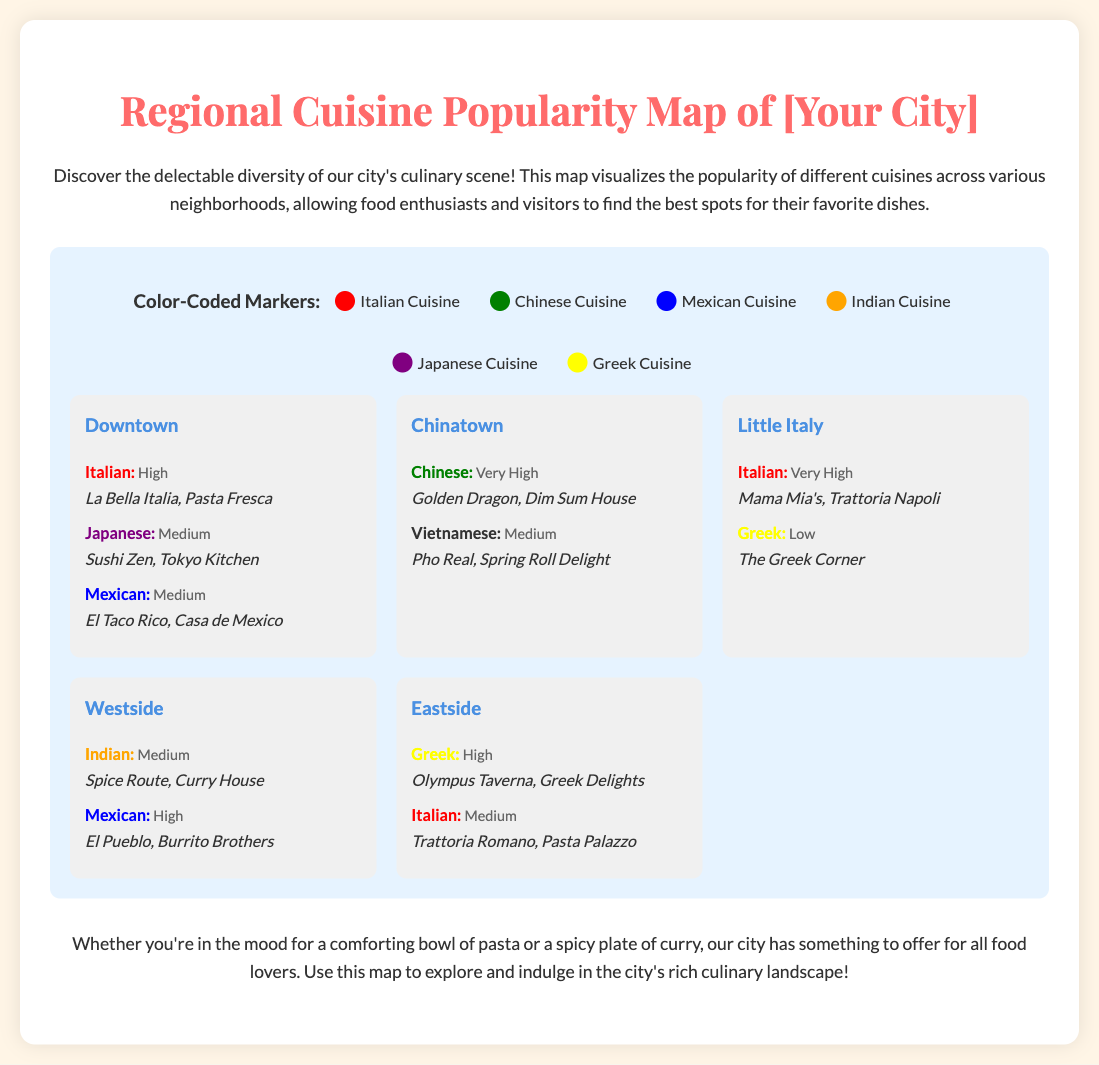what cuisine is very popular in Chinatown? The document states that Chinese cuisine has a frequency of "Very High" in Chinatown.
Answer: Chinese how many Italian restaurants are mentioned in Downtown? The document lists two Italian restaurants in Downtown: La Bella Italia and Pasta Fresca.
Answer: 2 which neighborhood has the highest frequency for Italian cuisine? According to the document, Little Italy has a frequency of "Very High" for Italian cuisine.
Answer: Little Italy what color represents Greek cuisine on the map? The document indicates that Greek cuisine is represented by yellow on the map.
Answer: Yellow how many cuisines are listed in the Westside neighborhood? The document lists two cuisines in the Westside: Indian and Mexican.
Answer: 2 which two neighborhoods feature medium frequency for Mexican cuisine? The document mentions Downtown and Westside as having a medium frequency for Mexican cuisine.
Answer: Downtown, Westside which cuisine is described as having a low frequency in Little Italy? The document states that Greek cuisine has a frequency of "Low" in Little Italy.
Answer: Greek what is the dominant cuisine in Little Italy? The document indicates that Italian cuisine has a frequency of "Very High" in Little Italy.
Answer: Italian which neighborhood features both Greek and Italian cuisines? The document shows that Eastside features both Greek and Italian cuisines.
Answer: Eastside 